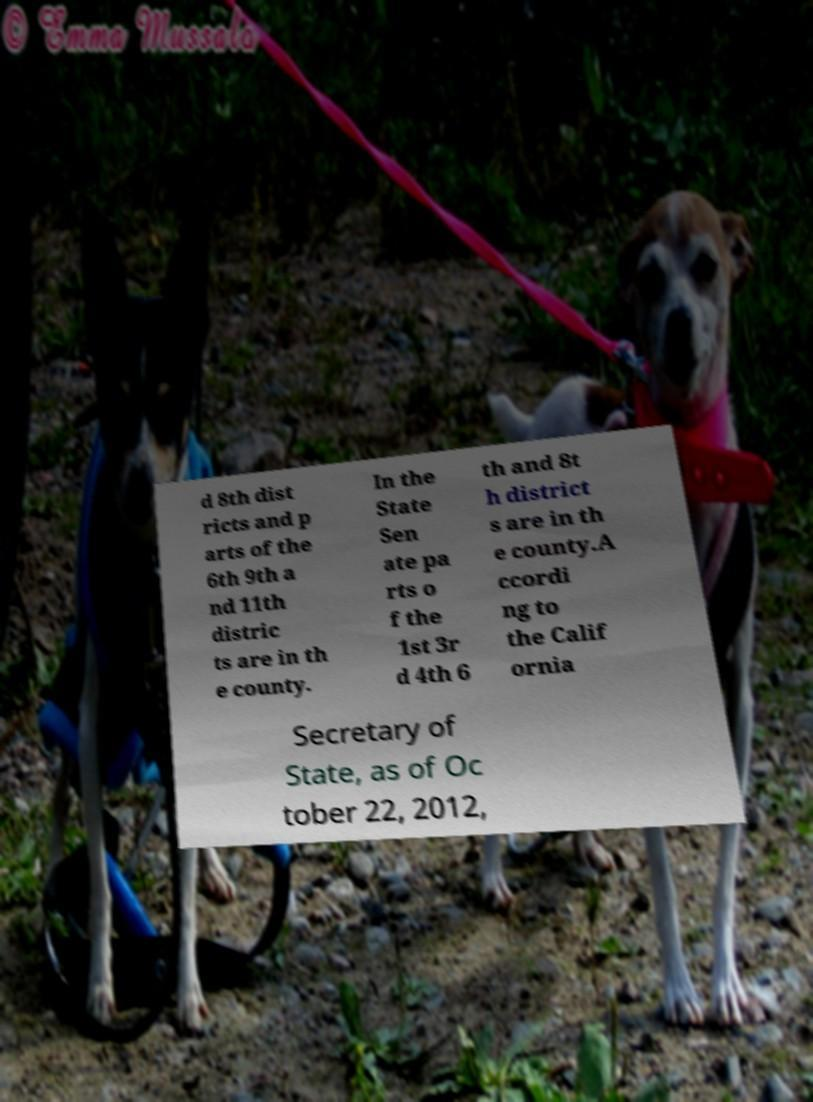Can you accurately transcribe the text from the provided image for me? d 8th dist ricts and p arts of the 6th 9th a nd 11th distric ts are in th e county. In the State Sen ate pa rts o f the 1st 3r d 4th 6 th and 8t h district s are in th e county.A ccordi ng to the Calif ornia Secretary of State, as of Oc tober 22, 2012, 